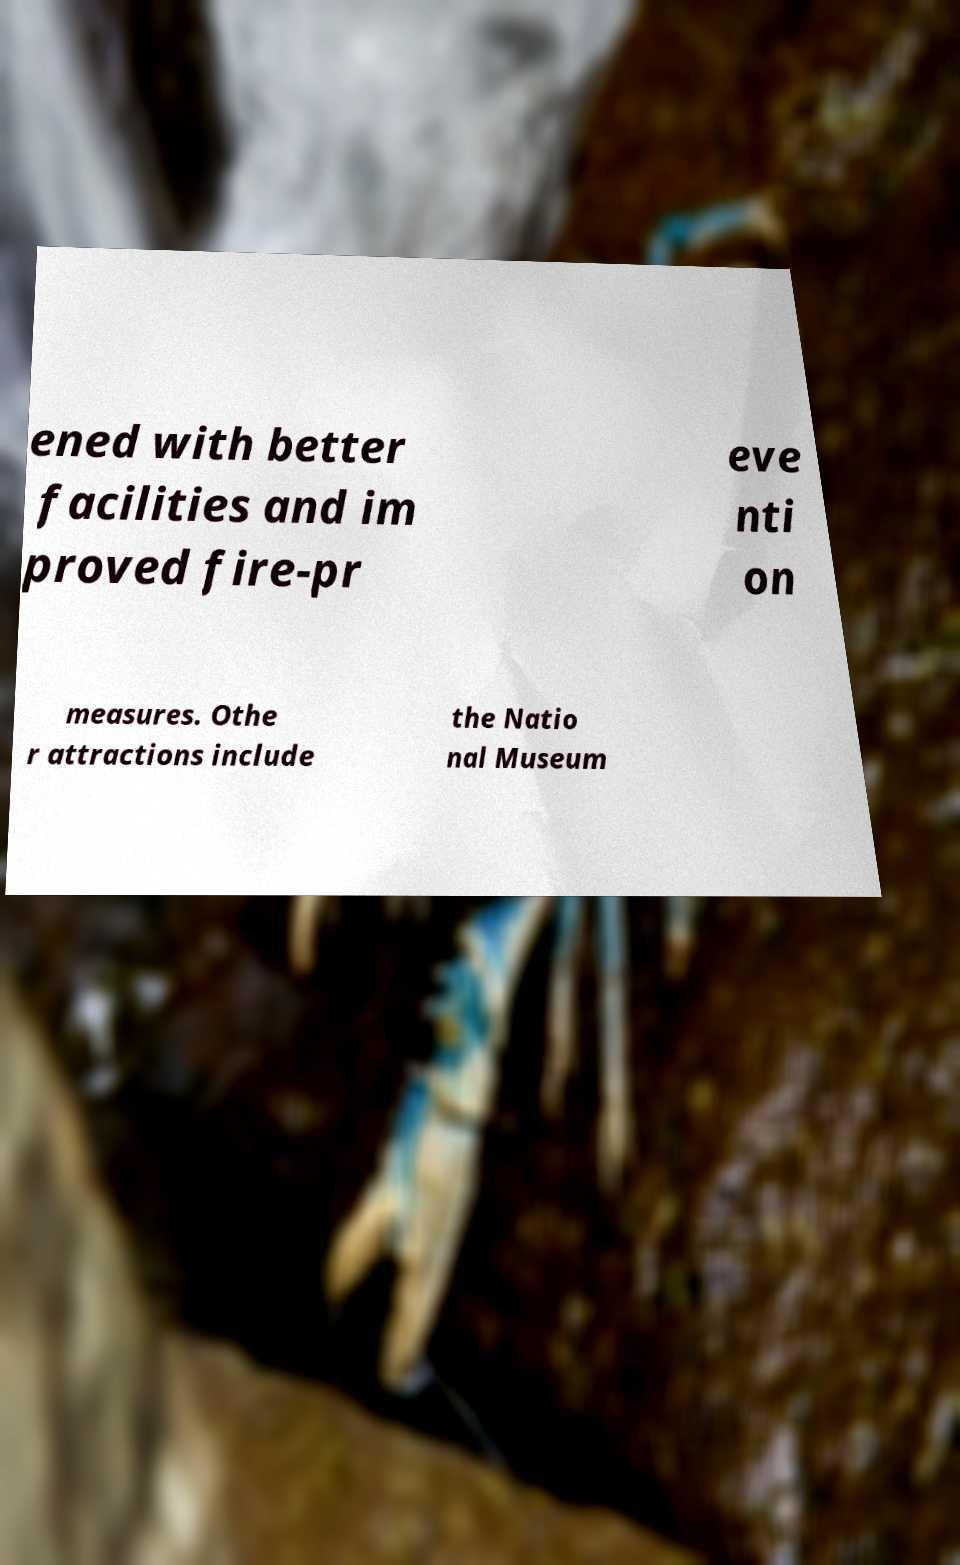Can you read and provide the text displayed in the image?This photo seems to have some interesting text. Can you extract and type it out for me? ened with better facilities and im proved fire-pr eve nti on measures. Othe r attractions include the Natio nal Museum 